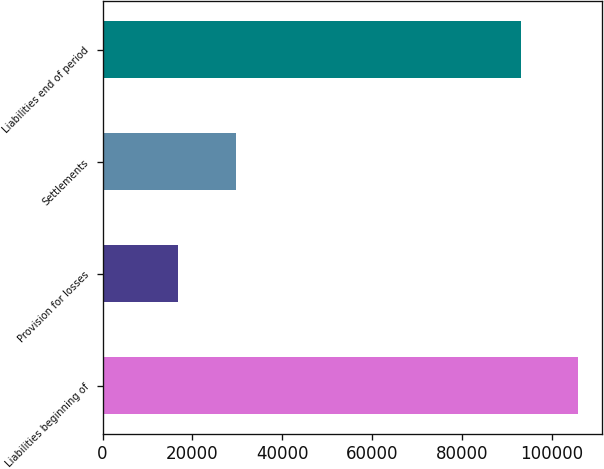Convert chart to OTSL. <chart><loc_0><loc_0><loc_500><loc_500><bar_chart><fcel>Liabilities beginning of<fcel>Provision for losses<fcel>Settlements<fcel>Liabilities end of period<nl><fcel>105914<fcel>16856<fcel>29713<fcel>93057<nl></chart> 